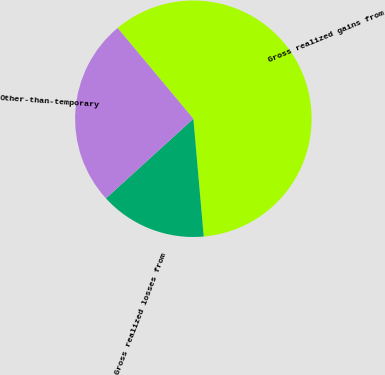Convert chart. <chart><loc_0><loc_0><loc_500><loc_500><pie_chart><fcel>Gross realized gains from<fcel>Gross realized losses from<fcel>Other-than-temporary<nl><fcel>59.67%<fcel>14.64%<fcel>25.69%<nl></chart> 